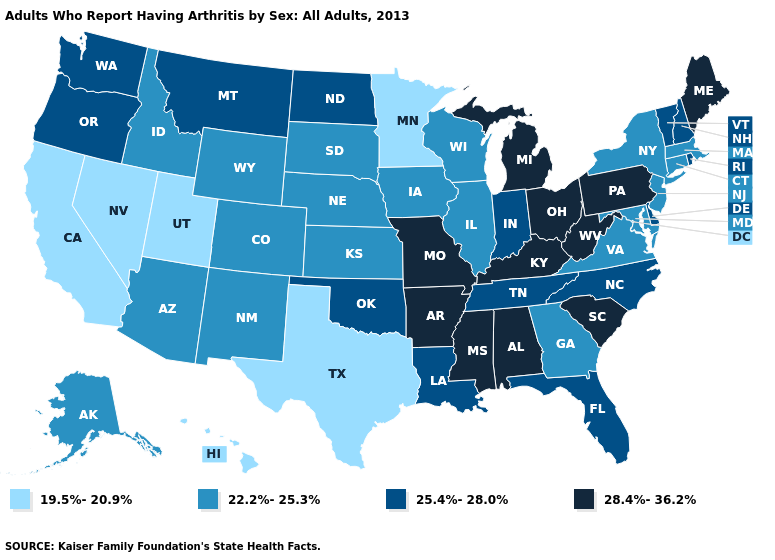Is the legend a continuous bar?
Give a very brief answer. No. What is the highest value in the USA?
Be succinct. 28.4%-36.2%. Among the states that border New York , which have the highest value?
Answer briefly. Pennsylvania. Does Utah have the highest value in the West?
Short answer required. No. Does Louisiana have the highest value in the USA?
Answer briefly. No. Does Hawaii have the lowest value in the USA?
Keep it brief. Yes. Among the states that border Michigan , which have the lowest value?
Short answer required. Wisconsin. Does the first symbol in the legend represent the smallest category?
Answer briefly. Yes. Does South Carolina have the same value as North Carolina?
Write a very short answer. No. What is the lowest value in the South?
Quick response, please. 19.5%-20.9%. Does Georgia have a lower value than Rhode Island?
Concise answer only. Yes. Does Arizona have the same value as Alabama?
Write a very short answer. No. What is the lowest value in the MidWest?
Quick response, please. 19.5%-20.9%. What is the value of Wisconsin?
Give a very brief answer. 22.2%-25.3%. Name the states that have a value in the range 19.5%-20.9%?
Answer briefly. California, Hawaii, Minnesota, Nevada, Texas, Utah. 